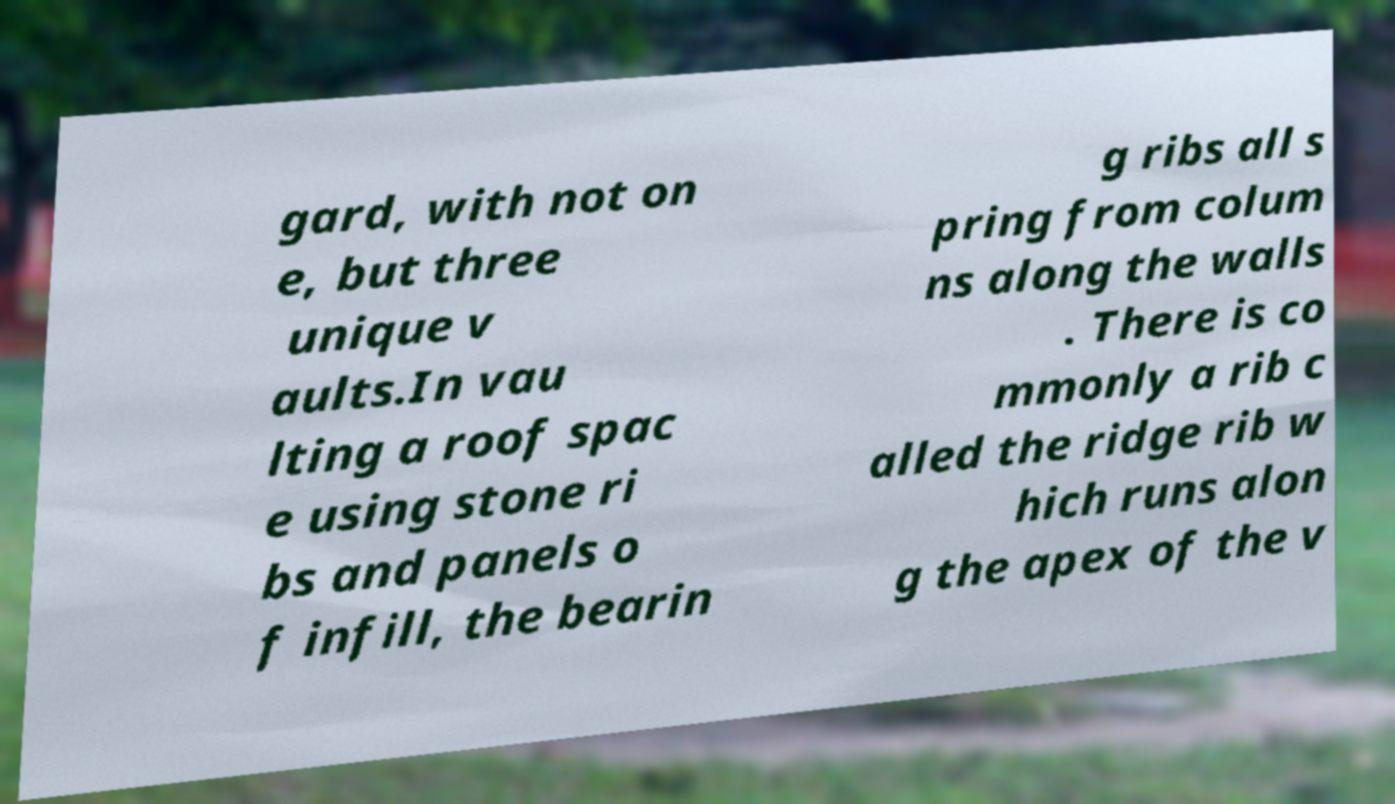Could you extract and type out the text from this image? gard, with not on e, but three unique v aults.In vau lting a roof spac e using stone ri bs and panels o f infill, the bearin g ribs all s pring from colum ns along the walls . There is co mmonly a rib c alled the ridge rib w hich runs alon g the apex of the v 